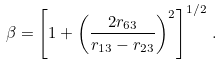Convert formula to latex. <formula><loc_0><loc_0><loc_500><loc_500>\beta = \left [ 1 + \left ( \frac { 2 r _ { 6 3 } } { r _ { 1 3 } - r _ { 2 3 } } \right ) ^ { 2 } \right ] ^ { 1 / 2 } \, .</formula> 